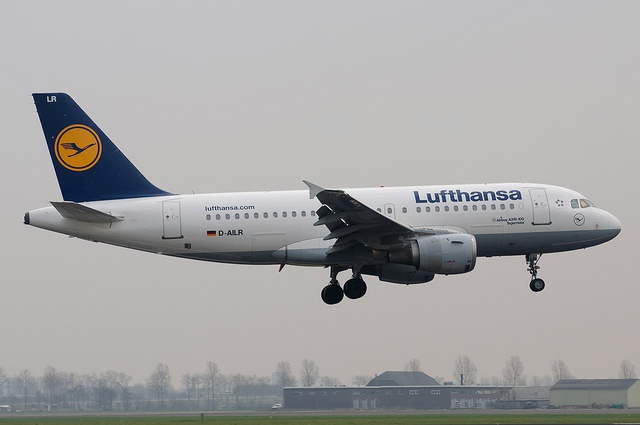Describe the objects in this image and their specific colors. I can see airplane in lightgray, darkgray, black, and gray tones and car in lightgray, darkgray, gray, and darkblue tones in this image. 